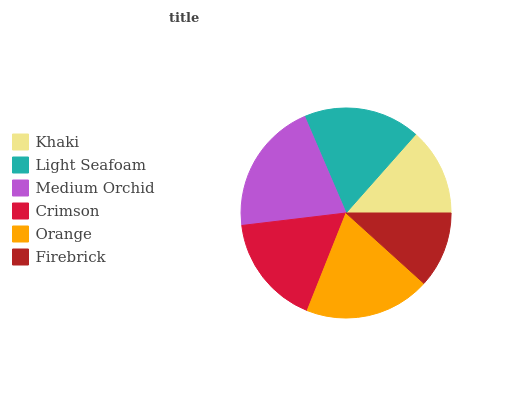Is Firebrick the minimum?
Answer yes or no. Yes. Is Medium Orchid the maximum?
Answer yes or no. Yes. Is Light Seafoam the minimum?
Answer yes or no. No. Is Light Seafoam the maximum?
Answer yes or no. No. Is Light Seafoam greater than Khaki?
Answer yes or no. Yes. Is Khaki less than Light Seafoam?
Answer yes or no. Yes. Is Khaki greater than Light Seafoam?
Answer yes or no. No. Is Light Seafoam less than Khaki?
Answer yes or no. No. Is Light Seafoam the high median?
Answer yes or no. Yes. Is Crimson the low median?
Answer yes or no. Yes. Is Orange the high median?
Answer yes or no. No. Is Khaki the low median?
Answer yes or no. No. 